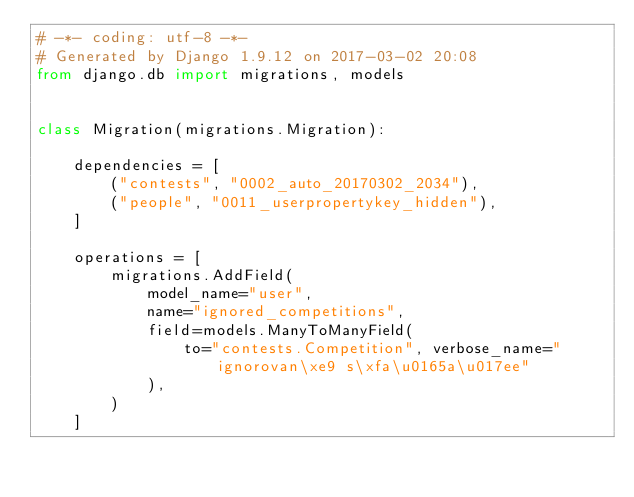<code> <loc_0><loc_0><loc_500><loc_500><_Python_># -*- coding: utf-8 -*-
# Generated by Django 1.9.12 on 2017-03-02 20:08
from django.db import migrations, models


class Migration(migrations.Migration):

    dependencies = [
        ("contests", "0002_auto_20170302_2034"),
        ("people", "0011_userpropertykey_hidden"),
    ]

    operations = [
        migrations.AddField(
            model_name="user",
            name="ignored_competitions",
            field=models.ManyToManyField(
                to="contests.Competition", verbose_name="ignorovan\xe9 s\xfa\u0165a\u017ee"
            ),
        )
    ]
</code> 